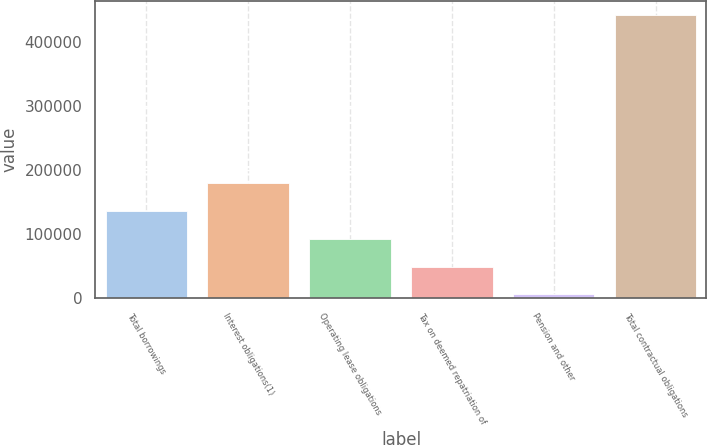Convert chart. <chart><loc_0><loc_0><loc_500><loc_500><bar_chart><fcel>Total borrowings<fcel>Interest obligations(1)<fcel>Operating lease obligations<fcel>Tax on deemed repatriation of<fcel>Pension and other<fcel>Total contractual obligations<nl><fcel>136551<fcel>180202<fcel>92899.6<fcel>49248.3<fcel>5597<fcel>442110<nl></chart> 